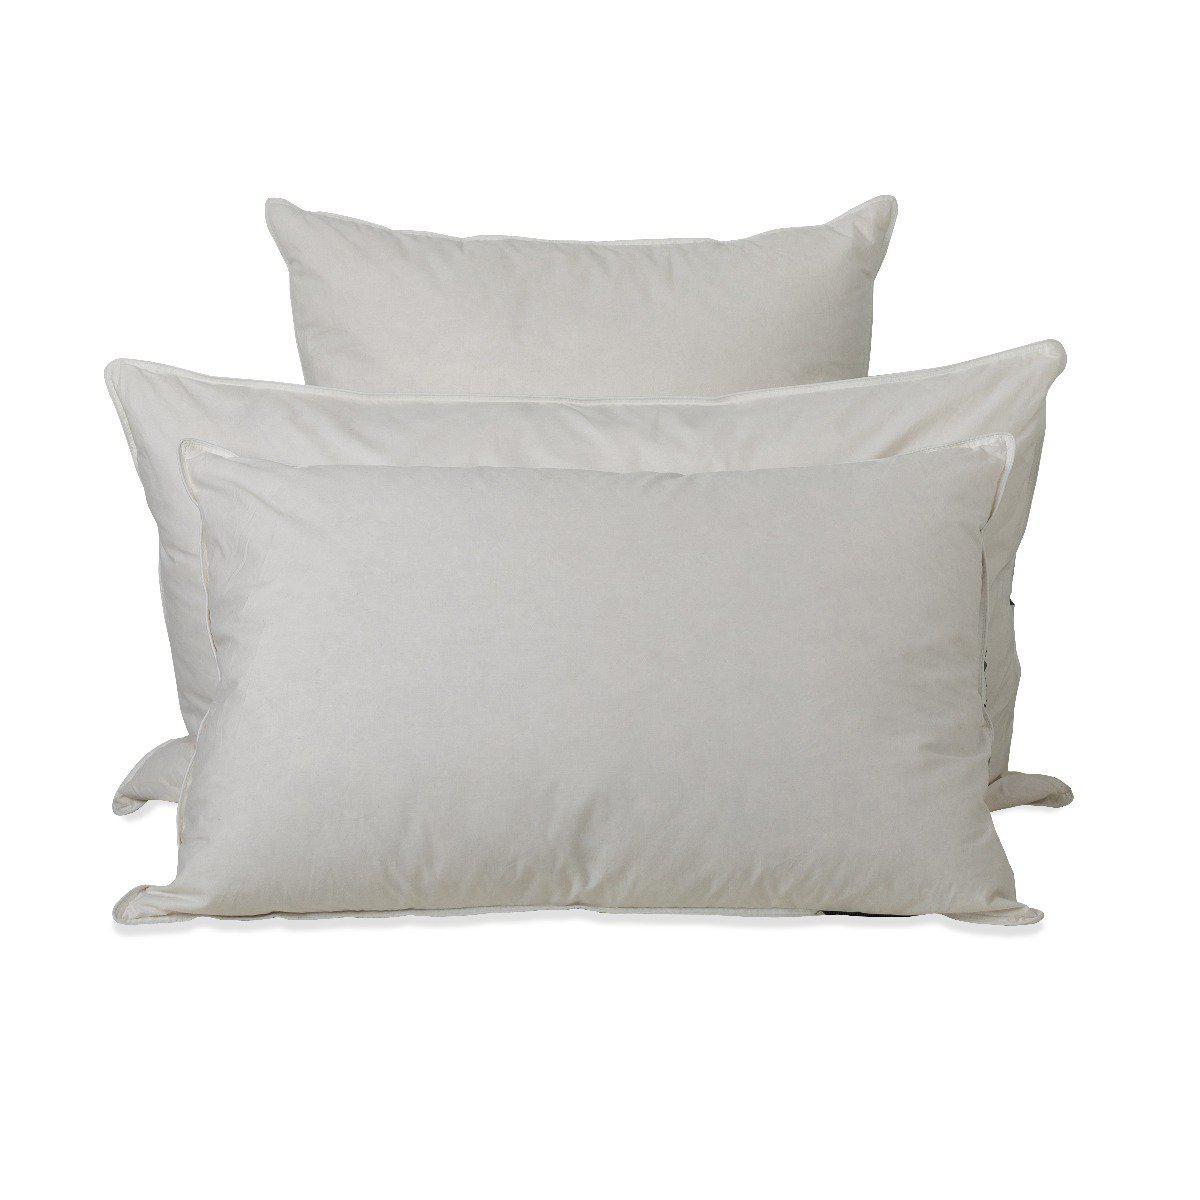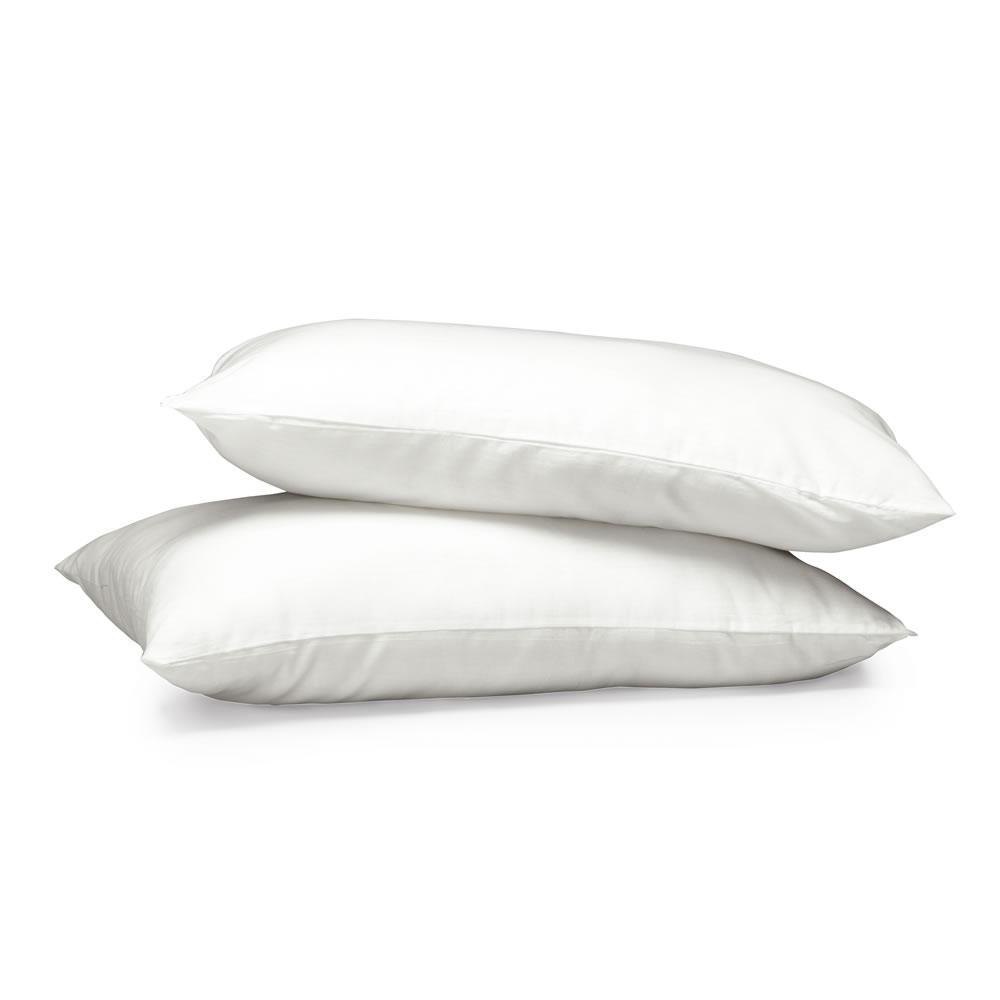The first image is the image on the left, the second image is the image on the right. Evaluate the accuracy of this statement regarding the images: "An image with exactly two white pillows includes at least one white feather at the bottom right.". Is it true? Answer yes or no. No. The first image is the image on the left, the second image is the image on the right. For the images displayed, is the sentence "Two pillows are stacked on each other in the image on the right." factually correct? Answer yes or no. Yes. 